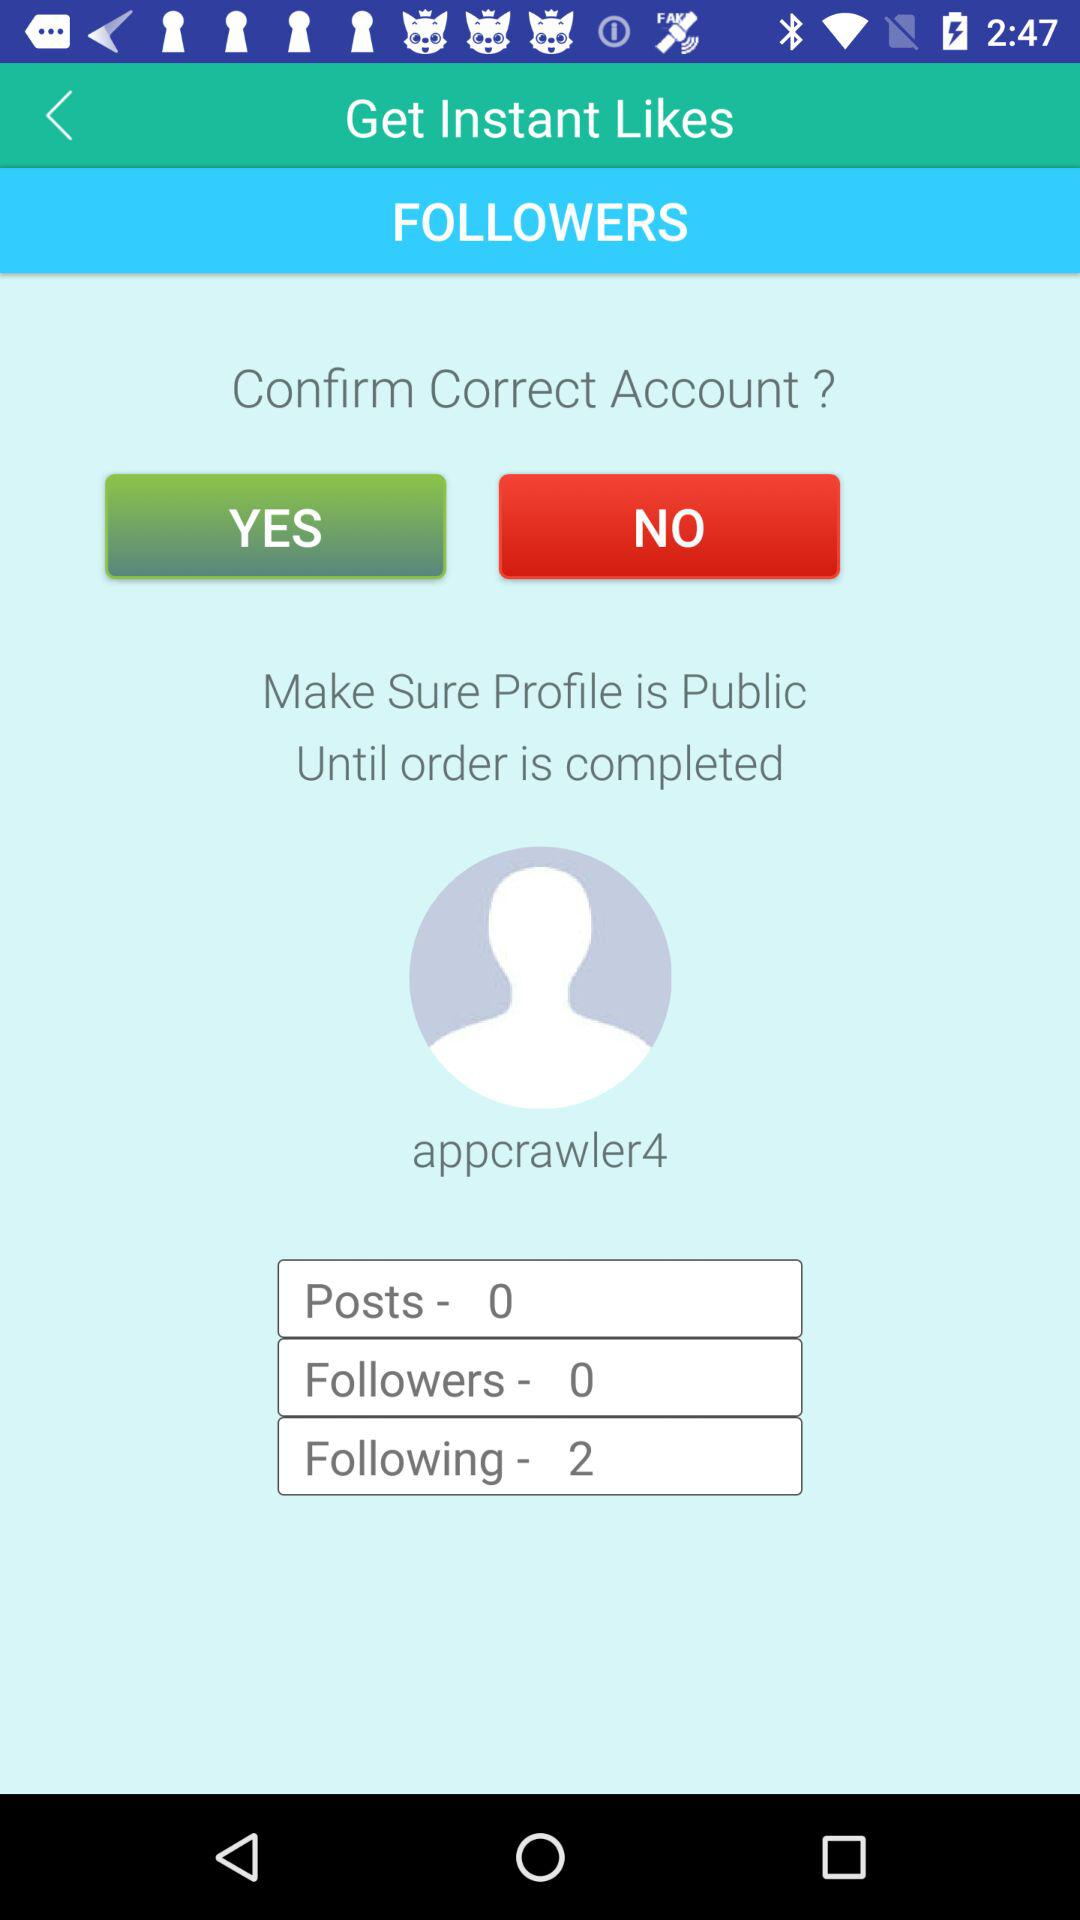How many posts are there? There are zero posts. 